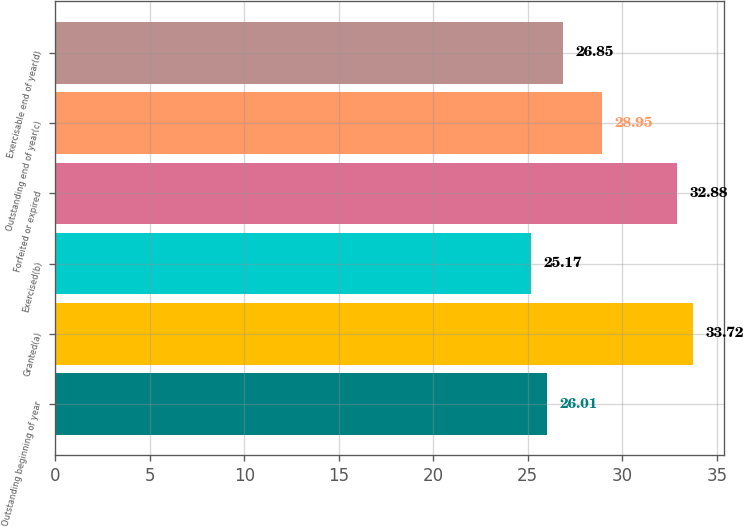<chart> <loc_0><loc_0><loc_500><loc_500><bar_chart><fcel>Outstanding beginning of year<fcel>Granted(a)<fcel>Exercised(b)<fcel>Forfeited or expired<fcel>Outstanding end of year(c)<fcel>Exercisable end of year(d)<nl><fcel>26.01<fcel>33.72<fcel>25.17<fcel>32.88<fcel>28.95<fcel>26.85<nl></chart> 